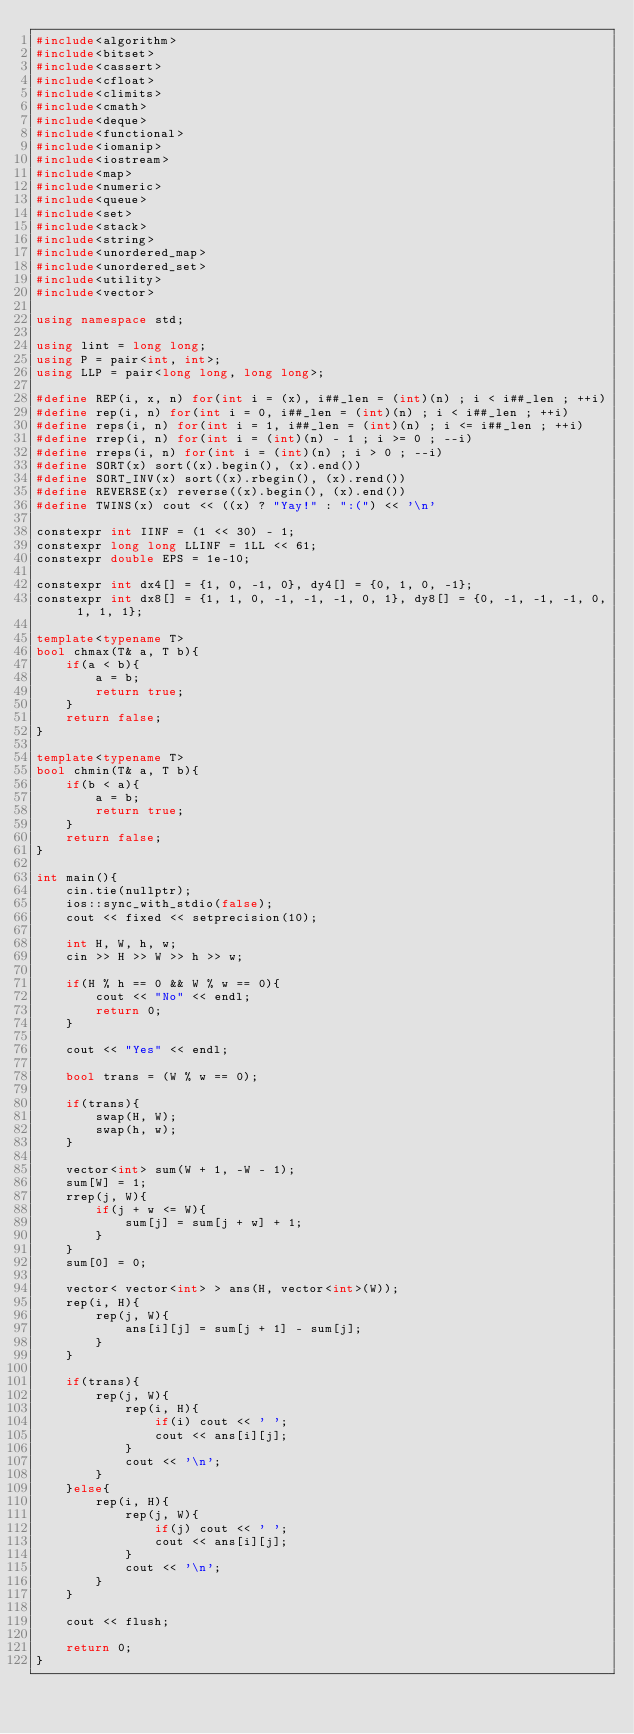Convert code to text. <code><loc_0><loc_0><loc_500><loc_500><_C++_>#include<algorithm>
#include<bitset>
#include<cassert>
#include<cfloat>
#include<climits>
#include<cmath>
#include<deque>
#include<functional>
#include<iomanip>
#include<iostream>
#include<map>
#include<numeric>
#include<queue>
#include<set>
#include<stack>
#include<string>
#include<unordered_map>
#include<unordered_set>
#include<utility>
#include<vector>

using namespace std;

using lint = long long;
using P = pair<int, int>;
using LLP = pair<long long, long long>;

#define REP(i, x, n) for(int i = (x), i##_len = (int)(n) ; i < i##_len ; ++i)
#define rep(i, n) for(int i = 0, i##_len = (int)(n) ; i < i##_len ; ++i)
#define reps(i, n) for(int i = 1, i##_len = (int)(n) ; i <= i##_len ; ++i)
#define rrep(i, n) for(int i = (int)(n) - 1 ; i >= 0 ; --i)
#define rreps(i, n) for(int i = (int)(n) ; i > 0 ; --i)
#define SORT(x) sort((x).begin(), (x).end())
#define SORT_INV(x) sort((x).rbegin(), (x).rend())
#define REVERSE(x) reverse((x).begin(), (x).end())
#define TWINS(x) cout << ((x) ? "Yay!" : ":(") << '\n'

constexpr int IINF = (1 << 30) - 1;
constexpr long long LLINF = 1LL << 61;
constexpr double EPS = 1e-10;

constexpr int dx4[] = {1, 0, -1, 0}, dy4[] = {0, 1, 0, -1};
constexpr int dx8[] = {1, 1, 0, -1, -1, -1, 0, 1}, dy8[] = {0, -1, -1, -1, 0, 1, 1, 1};

template<typename T>
bool chmax(T& a, T b){
    if(a < b){
        a = b;
        return true;
    }
    return false;
}

template<typename T>
bool chmin(T& a, T b){
    if(b < a){
        a = b;
        return true;
    }
    return false;
}

int main(){
    cin.tie(nullptr);
    ios::sync_with_stdio(false);
    cout << fixed << setprecision(10);

    int H, W, h, w;
    cin >> H >> W >> h >> w;

    if(H % h == 0 && W % w == 0){
        cout << "No" << endl;
        return 0;
    }

    cout << "Yes" << endl;

    bool trans = (W % w == 0);

    if(trans){
        swap(H, W);
        swap(h, w);
    }

    vector<int> sum(W + 1, -W - 1);
    sum[W] = 1;
    rrep(j, W){
        if(j + w <= W){
            sum[j] = sum[j + w] + 1;
        }
    }
    sum[0] = 0;

    vector< vector<int> > ans(H, vector<int>(W));
    rep(i, H){
        rep(j, W){
            ans[i][j] = sum[j + 1] - sum[j];
        }
    }

    if(trans){
        rep(j, W){
            rep(i, H){
                if(i) cout << ' ';
                cout << ans[i][j];
            }
            cout << '\n';
        }
    }else{
        rep(i, H){
            rep(j, W){
                if(j) cout << ' ';
                cout << ans[i][j];
            }
            cout << '\n';
        }
    }

    cout << flush;

    return 0;
}</code> 